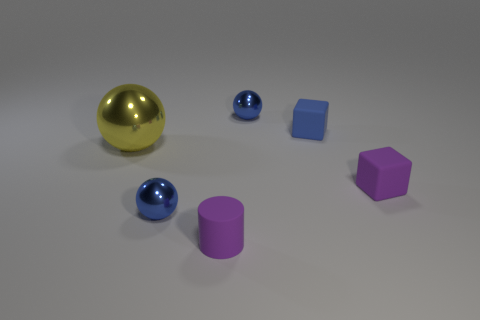What number of tiny balls have the same material as the big yellow thing?
Offer a terse response. 2. What number of large things are red metallic things or purple matte blocks?
Make the answer very short. 0. The rubber thing that is on the left side of the purple cube and in front of the tiny blue rubber cube has what shape?
Ensure brevity in your answer.  Cylinder. Does the small cylinder have the same material as the blue block?
Provide a short and direct response. Yes. What color is the other block that is the same size as the purple rubber cube?
Your response must be concise. Blue. There is a small thing that is both in front of the tiny blue rubber object and on the right side of the tiny purple cylinder; what is its color?
Your answer should be very brief. Purple. What shape is the rubber object that is the same color as the tiny cylinder?
Your answer should be very brief. Cube. There is a yellow shiny object behind the small matte object in front of the blue metallic thing in front of the large yellow object; what size is it?
Provide a succinct answer. Large. What material is the cylinder?
Provide a short and direct response. Rubber. Are the blue cube and the cylinder on the right side of the big thing made of the same material?
Offer a terse response. Yes. 